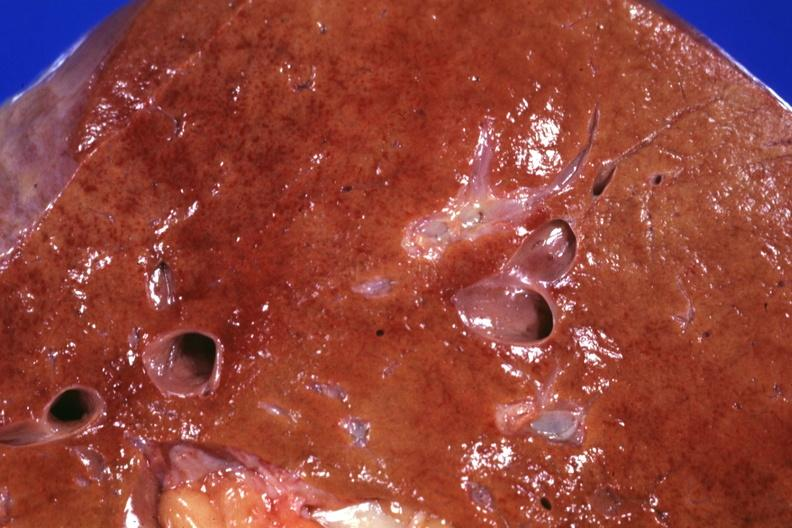what is present?
Answer the question using a single word or phrase. Hepatobiliary 